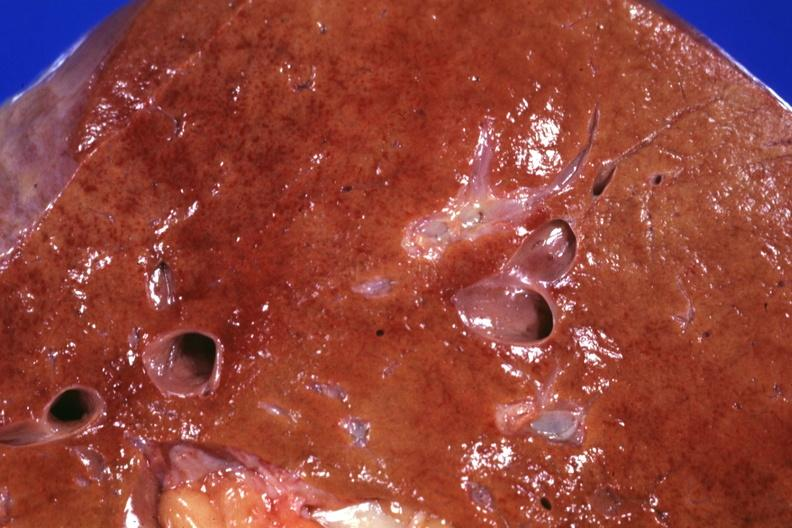what is present?
Answer the question using a single word or phrase. Hepatobiliary 